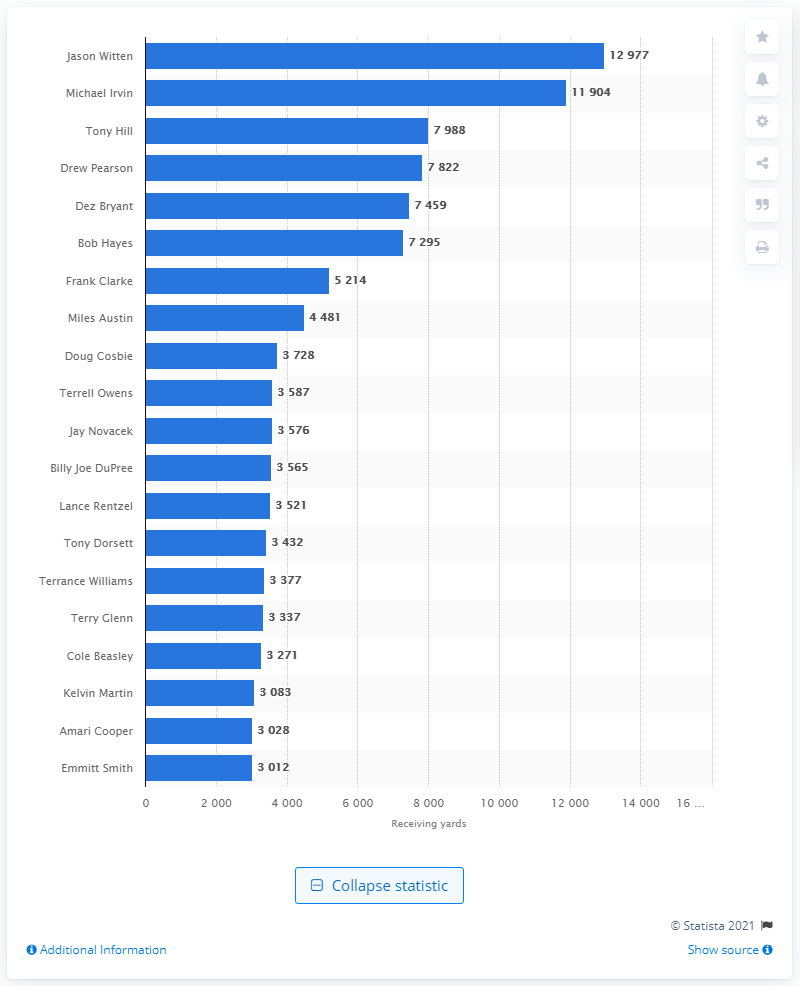Highlight a few significant elements in this photo. The career receiving leader of the Dallas Cowboys is Jason Witten. 